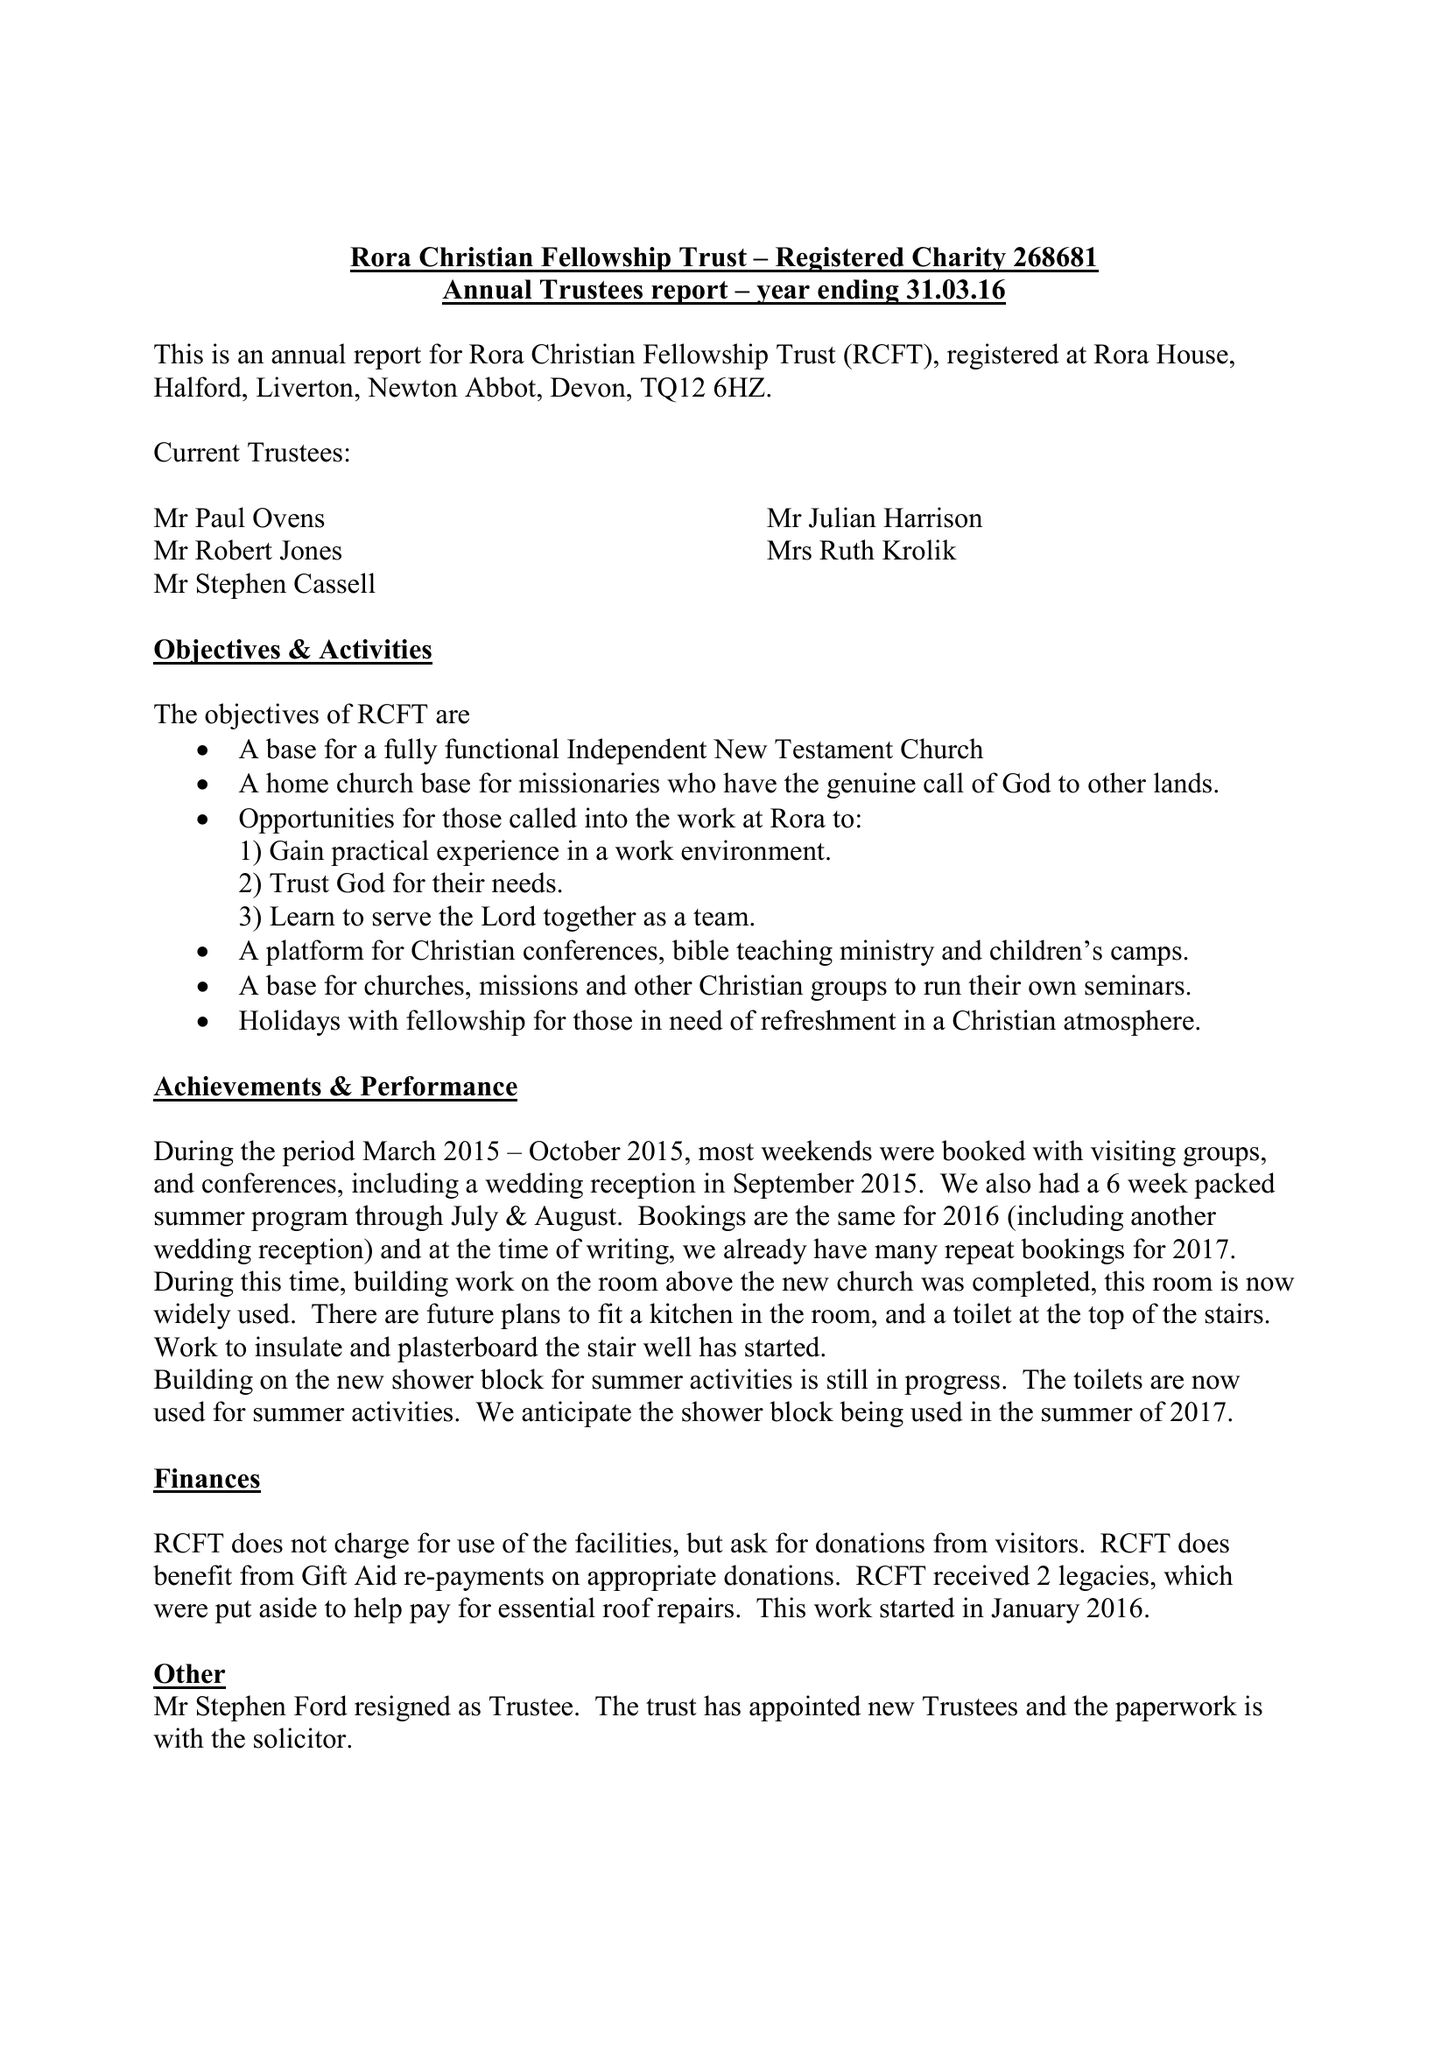What is the value for the charity_number?
Answer the question using a single word or phrase. 268681 